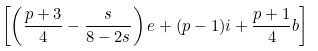Convert formula to latex. <formula><loc_0><loc_0><loc_500><loc_500>\left [ \left ( \frac { p + 3 } { 4 } - \frac { s } { 8 - 2 s } \right ) e + ( p - 1 ) i + \frac { p + 1 } { 4 } b \right ]</formula> 